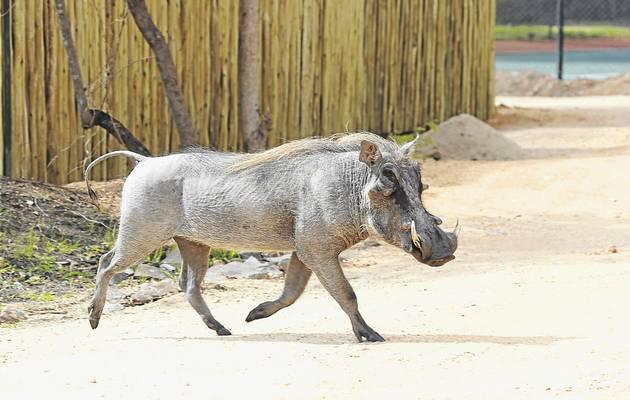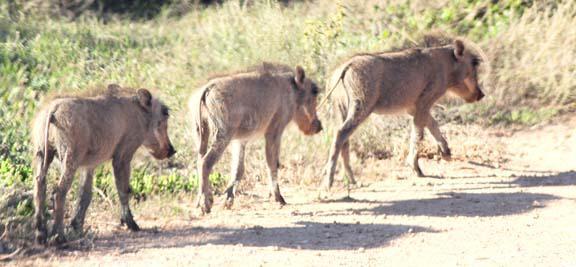The first image is the image on the left, the second image is the image on the right. Assess this claim about the two images: "The right image contains one adult warthog that is standing beside two baby warthogs.". Correct or not? Answer yes or no. No. The first image is the image on the left, the second image is the image on the right. For the images displayed, is the sentence "An image includes a wild cat and a warthog, and the action scene features kicked-up dust." factually correct? Answer yes or no. No. 